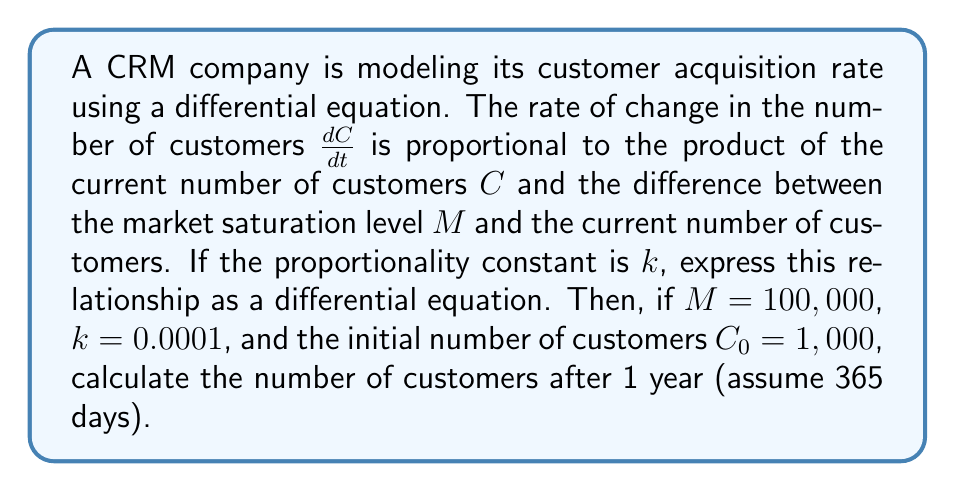Help me with this question. 1. First, let's express the differential equation:

   $$\frac{dC}{dt} = kC(M-C)$$

   This is known as the logistic growth model.

2. To solve this equation, we need to use the logistic function:

   $$C(t) = \frac{M}{1 + (\frac{M}{C_0} - 1)e^{-kMt}}$$

3. Now, let's substitute the given values:
   $M = 100,000$
   $k = 0.0001$
   $C_0 = 1,000$
   $t = 365$ (days)

4. Plugging these into our equation:

   $$C(365) = \frac{100,000}{1 + (\frac{100,000}{1,000} - 1)e^{-0.0001 \cdot 100,000 \cdot 365}}$$

5. Simplify:
   $$C(365) = \frac{100,000}{1 + 99e^{-3650}}$$

6. Calculate $e^{-3650}$ (this is a very small number):
   $$e^{-3650} \approx 0$$

7. Therefore:
   $$C(365) \approx \frac{100,000}{1 + 99 \cdot 0} = \frac{100,000}{1} = 100,000$$

The number of customers after 1 year is approximately 100,000.
Answer: 100,000 customers 